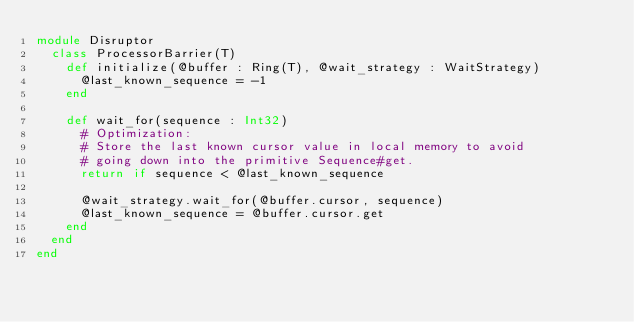<code> <loc_0><loc_0><loc_500><loc_500><_Crystal_>module Disruptor
  class ProcessorBarrier(T)
    def initialize(@buffer : Ring(T), @wait_strategy : WaitStrategy)
      @last_known_sequence = -1
    end

    def wait_for(sequence : Int32)
      # Optimization:
      # Store the last known cursor value in local memory to avoid
      # going down into the primitive Sequence#get.
      return if sequence < @last_known_sequence

      @wait_strategy.wait_for(@buffer.cursor, sequence)
      @last_known_sequence = @buffer.cursor.get
    end
  end
end
</code> 